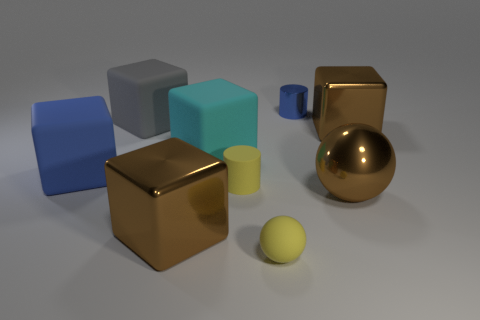Subtract all metal cubes. How many cubes are left? 3 Add 1 gray cylinders. How many objects exist? 10 Subtract all purple cylinders. How many brown cubes are left? 2 Subtract all brown spheres. How many spheres are left? 1 Subtract 1 spheres. How many spheres are left? 1 Add 9 gray rubber things. How many gray rubber things are left? 10 Add 9 tiny brown shiny cylinders. How many tiny brown shiny cylinders exist? 9 Subtract 0 brown cylinders. How many objects are left? 9 Subtract all cylinders. How many objects are left? 7 Subtract all green cylinders. Subtract all brown blocks. How many cylinders are left? 2 